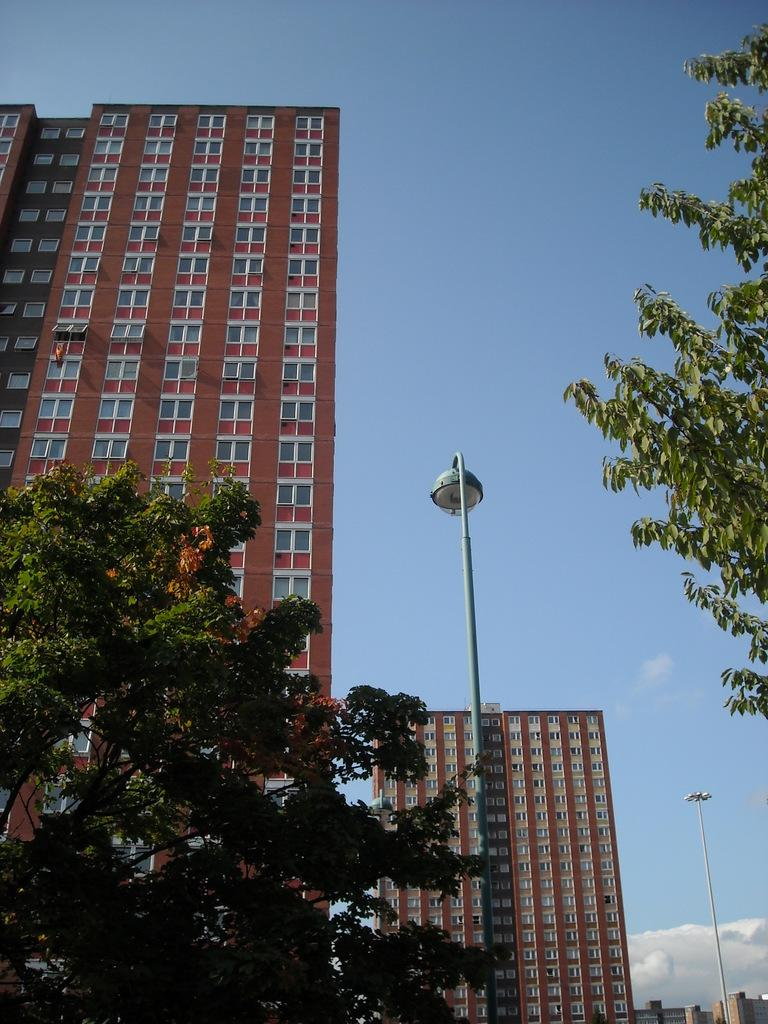What type of vegetation can be seen in the image? There are trees in the image. What type of structures are present in the image? There are lamp posts and buildings in the image. What is visible in the sky at the top of the image? There are clouds in the sky at the top of the image. Can you see any ants carrying a plough in the image? There are no ants or ploughs present in the image. What type of place is depicted in the image? The image does not depict a specific place; it shows trees, lamp posts, buildings, and clouds. 